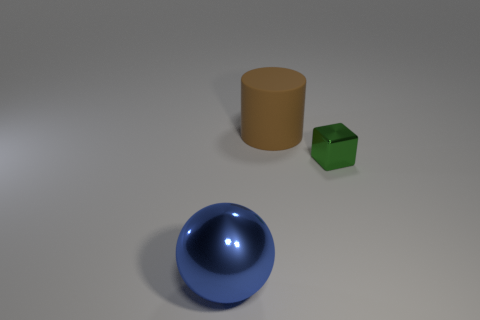Are there any other things that are the same size as the shiny block?
Give a very brief answer. No. What number of matte objects are big spheres or purple spheres?
Keep it short and to the point. 0. Are any big metal objects visible?
Keep it short and to the point. Yes. The metallic object that is on the right side of the big object in front of the metallic block is what color?
Offer a very short reply. Green. How many other things are the same color as the large ball?
Give a very brief answer. 0. What number of objects are either blue metal objects or objects that are on the left side of the small green cube?
Keep it short and to the point. 2. What is the color of the object that is in front of the small metal cube?
Give a very brief answer. Blue. What shape is the green metal thing?
Keep it short and to the point. Cube. What material is the big blue object that is to the left of the big object that is to the right of the blue shiny sphere?
Your answer should be very brief. Metal. How many other objects are there of the same material as the blue thing?
Ensure brevity in your answer.  1. 